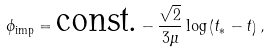Convert formula to latex. <formula><loc_0><loc_0><loc_500><loc_500>\phi _ { \text {imp} } = \text {const.} - \frac { \sqrt { 2 } } { 3 \mu } \log \left ( t _ { \ast } - t \right ) ,</formula> 